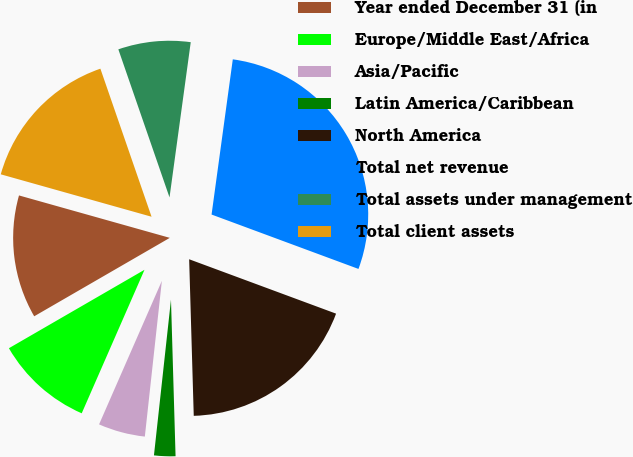Convert chart to OTSL. <chart><loc_0><loc_0><loc_500><loc_500><pie_chart><fcel>Year ended December 31 (in<fcel>Europe/Middle East/Africa<fcel>Asia/Pacific<fcel>Latin America/Caribbean<fcel>North America<fcel>Total net revenue<fcel>Total assets under management<fcel>Total client assets<nl><fcel>12.71%<fcel>10.09%<fcel>4.83%<fcel>2.2%<fcel>18.89%<fcel>28.48%<fcel>7.46%<fcel>15.34%<nl></chart> 